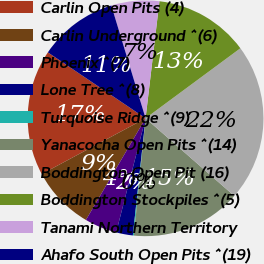<chart> <loc_0><loc_0><loc_500><loc_500><pie_chart><fcel>Carlin Open Pits (4)<fcel>Carlin Underground ^(6)<fcel>Phoenix ^(7)<fcel>Lone Tree ^(8)<fcel>Turquoise Ridge ^(9)<fcel>Yanacocha Open Pits ^(14)<fcel>Boddington Open Pit (16)<fcel>Boddington Stockpiles ^(5)<fcel>Tanami Northern Territory<fcel>Ahafo South Open Pits ^(19)<nl><fcel>17.29%<fcel>8.71%<fcel>4.43%<fcel>2.29%<fcel>0.14%<fcel>15.14%<fcel>21.57%<fcel>13.0%<fcel>6.57%<fcel>10.86%<nl></chart> 